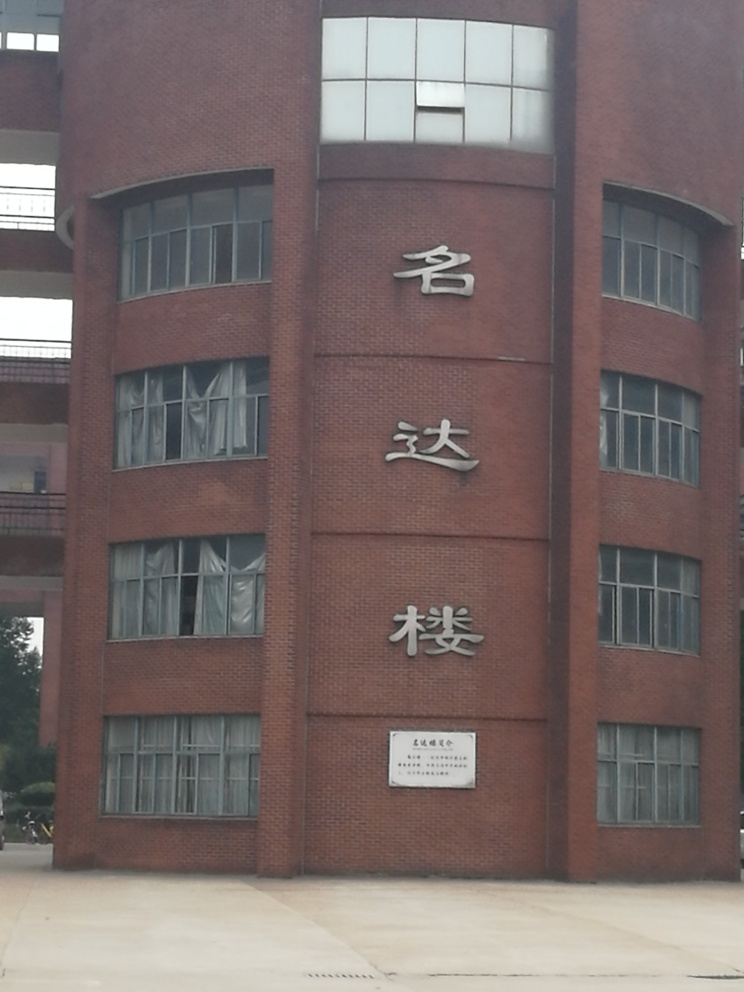Can you provide more details about the architectural style and features visible in this building? The building in the image exhibits a modern architectural style with a utilitarian design. It's constructed using red bricks, which give it a robust and traditional appearance. The structure has symmetrical windows, which contribute to its functional aesthetic. Its flat roof and linear geometric shape denote a contemporary architectural approach, focusing on simplicity and practicality. 